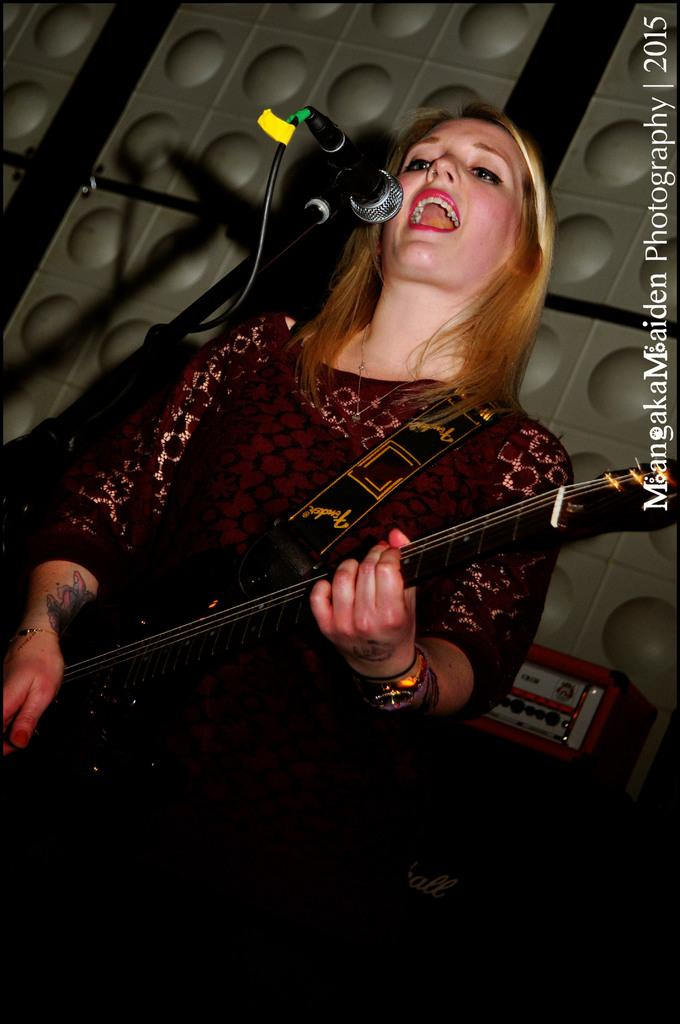Who is the main subject in the image? There is a woman in the image. What is the woman doing in the image? The woman is playing a guitar. What object is present in the image that is typically used for amplifying sound? There is a microphone in the image. Reasoning: Let' Let's think step by step in order to produce the conversation. We start by identifying the main subject of the image, which is the woman. Then, we describe what the woman is doing, which is playing a guitar. Finally, we mention the presence of a microphone, which is a relevant object in the context of the woman's activity. Absurd Question/Answer: What type of hat is the woman wearing in the image? There is no hat visible in the image. Is the woman taking a bath in the image? No, the woman is playing a guitar, not taking a bath. 